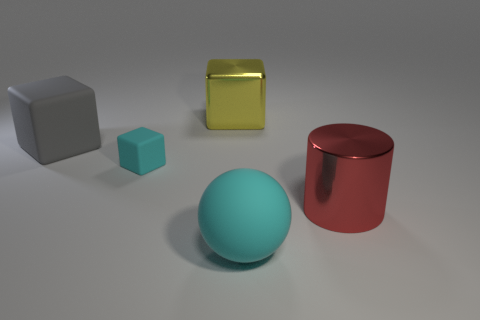Is the material of the red object the same as the large yellow cube?
Make the answer very short. Yes. How many things are large matte objects or large metallic cylinders?
Give a very brief answer. 3. What number of tiny gray blocks have the same material as the ball?
Your answer should be very brief. 0. There is another metallic thing that is the same shape as the big gray thing; what size is it?
Your response must be concise. Large. There is a small cube; are there any gray cubes on the left side of it?
Make the answer very short. Yes. What is the big gray block made of?
Offer a terse response. Rubber. Does the large rubber object right of the tiny block have the same color as the tiny block?
Your answer should be very brief. Yes. Are there any other things that have the same shape as the tiny matte thing?
Keep it short and to the point. Yes. The large matte object that is the same shape as the tiny rubber thing is what color?
Your answer should be compact. Gray. What is the material of the object behind the large gray rubber block?
Give a very brief answer. Metal. 